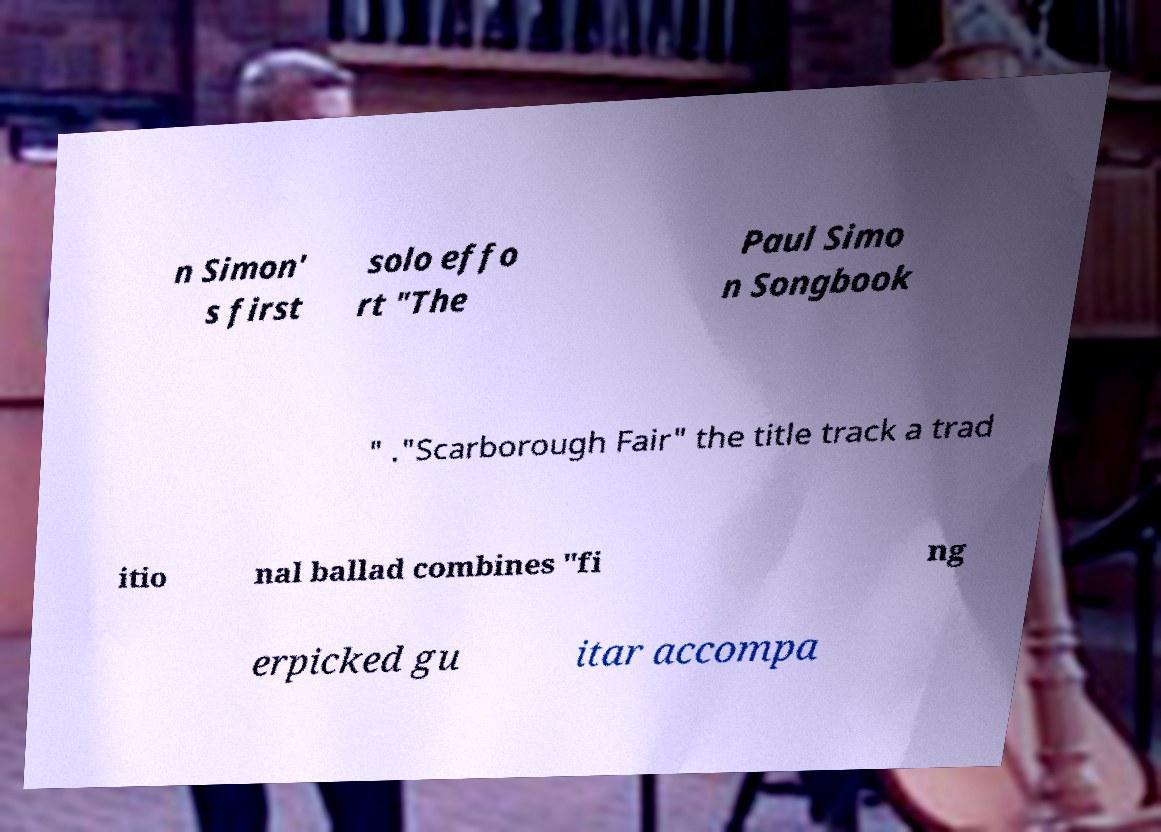Could you extract and type out the text from this image? n Simon' s first solo effo rt "The Paul Simo n Songbook " ."Scarborough Fair" the title track a trad itio nal ballad combines "fi ng erpicked gu itar accompa 